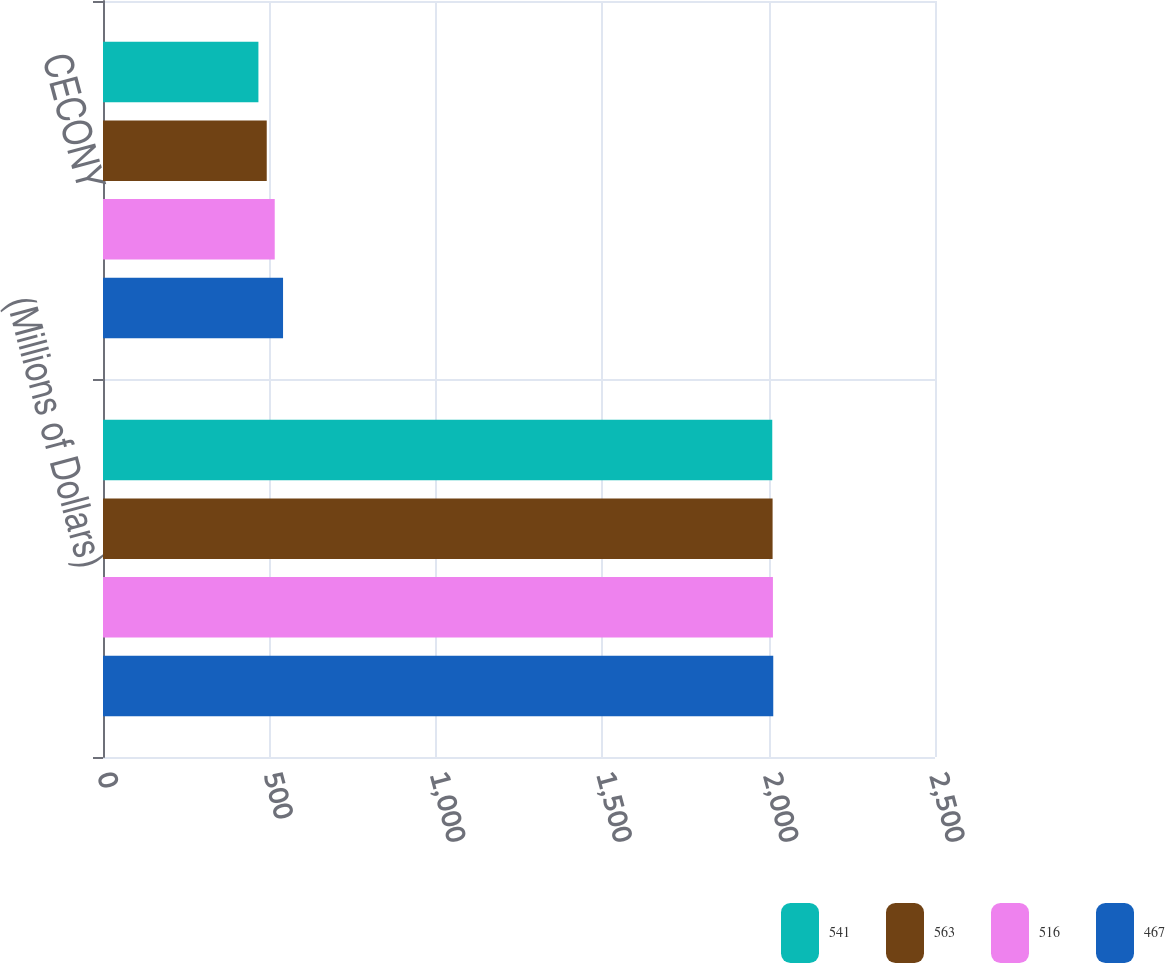Convert chart to OTSL. <chart><loc_0><loc_0><loc_500><loc_500><stacked_bar_chart><ecel><fcel>(Millions of Dollars)<fcel>CECONY<nl><fcel>541<fcel>2011<fcel>467<nl><fcel>563<fcel>2012<fcel>492<nl><fcel>516<fcel>2013<fcel>516<nl><fcel>467<fcel>2014<fcel>541<nl></chart> 